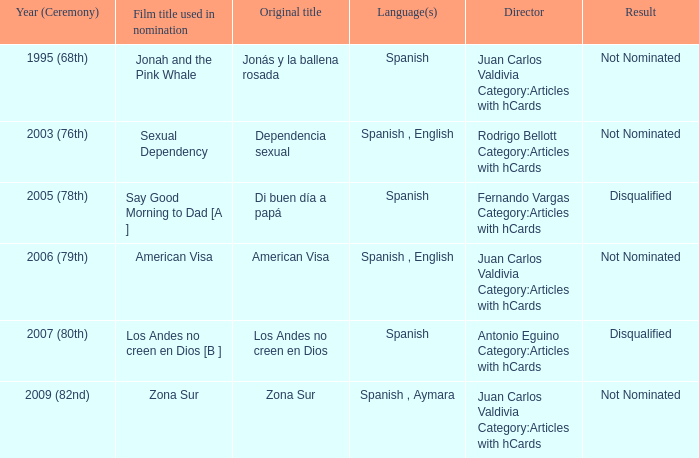What is the film name of dependencia sexual that was used in the nomination process? Sexual Dependency. Parse the full table. {'header': ['Year (Ceremony)', 'Film title used in nomination', 'Original title', 'Language(s)', 'Director', 'Result'], 'rows': [['1995 (68th)', 'Jonah and the Pink Whale', 'Jonás y la ballena rosada', 'Spanish', 'Juan Carlos Valdivia Category:Articles with hCards', 'Not Nominated'], ['2003 (76th)', 'Sexual Dependency', 'Dependencia sexual', 'Spanish , English', 'Rodrigo Bellott Category:Articles with hCards', 'Not Nominated'], ['2005 (78th)', 'Say Good Morning to Dad [A ]', 'Di buen día a papá', 'Spanish', 'Fernando Vargas Category:Articles with hCards', 'Disqualified'], ['2006 (79th)', 'American Visa', 'American Visa', 'Spanish , English', 'Juan Carlos Valdivia Category:Articles with hCards', 'Not Nominated'], ['2007 (80th)', 'Los Andes no creen en Dios [B ]', 'Los Andes no creen en Dios', 'Spanish', 'Antonio Eguino Category:Articles with hCards', 'Disqualified'], ['2009 (82nd)', 'Zona Sur', 'Zona Sur', 'Spanish , Aymara', 'Juan Carlos Valdivia Category:Articles with hCards', 'Not Nominated']]} 